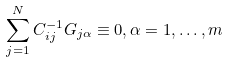Convert formula to latex. <formula><loc_0><loc_0><loc_500><loc_500>\sum _ { j = 1 } ^ { N } C ^ { - 1 } _ { i j } G _ { j \alpha } \equiv 0 , \alpha = 1 , \dots , m</formula> 